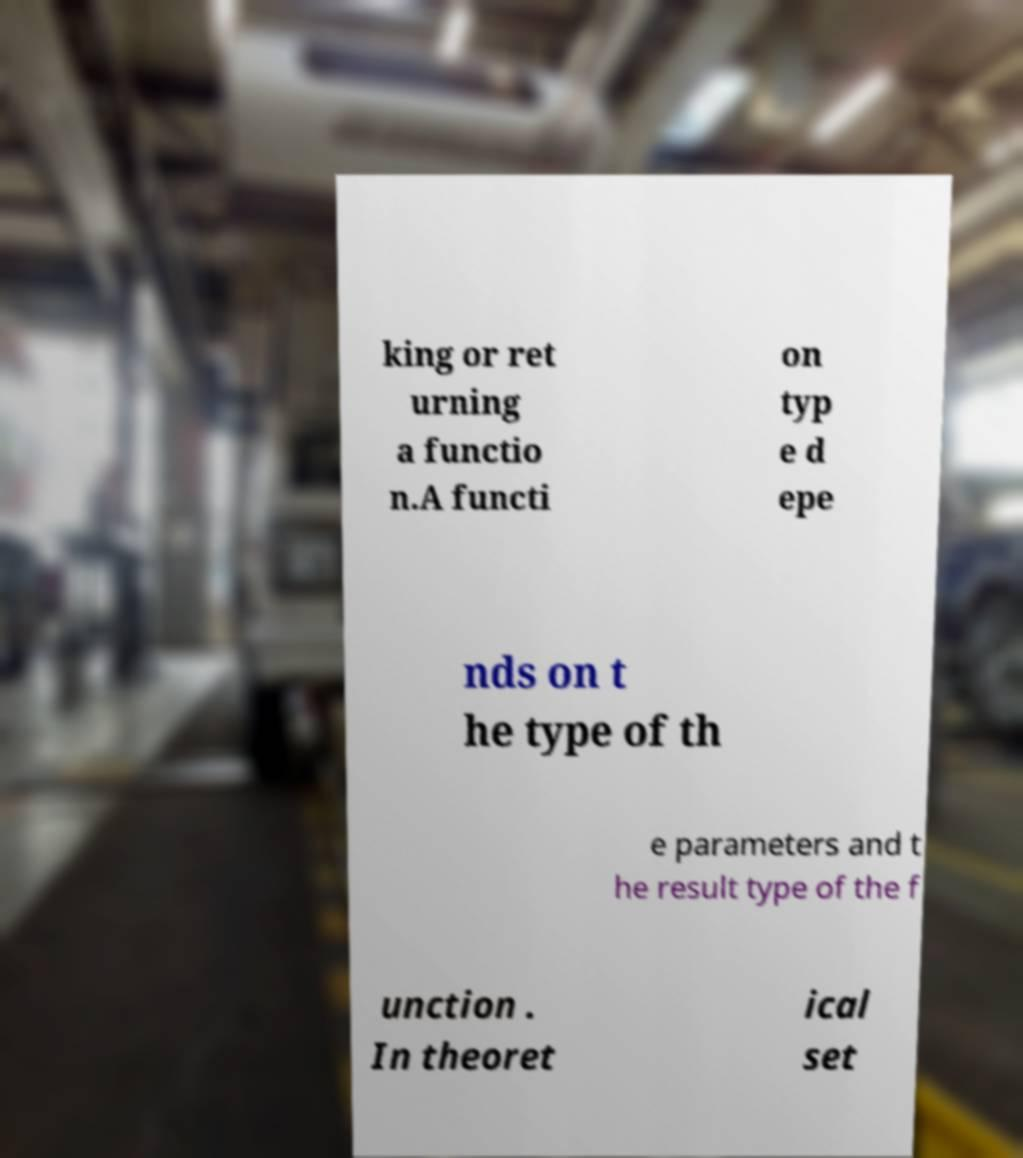I need the written content from this picture converted into text. Can you do that? king or ret urning a functio n.A functi on typ e d epe nds on t he type of th e parameters and t he result type of the f unction . In theoret ical set 